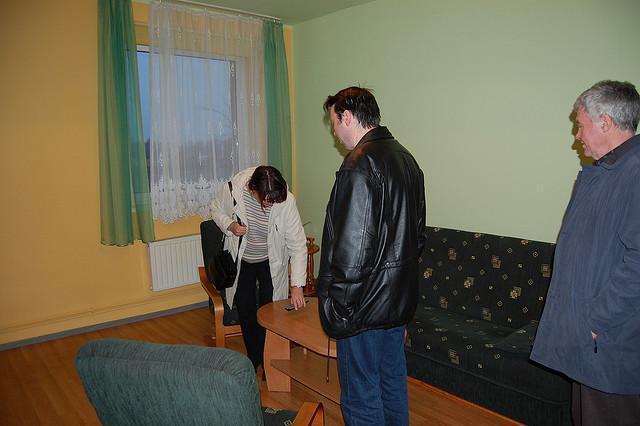How many couches are there?
Give a very brief answer. 2. How many people are there?
Give a very brief answer. 3. 